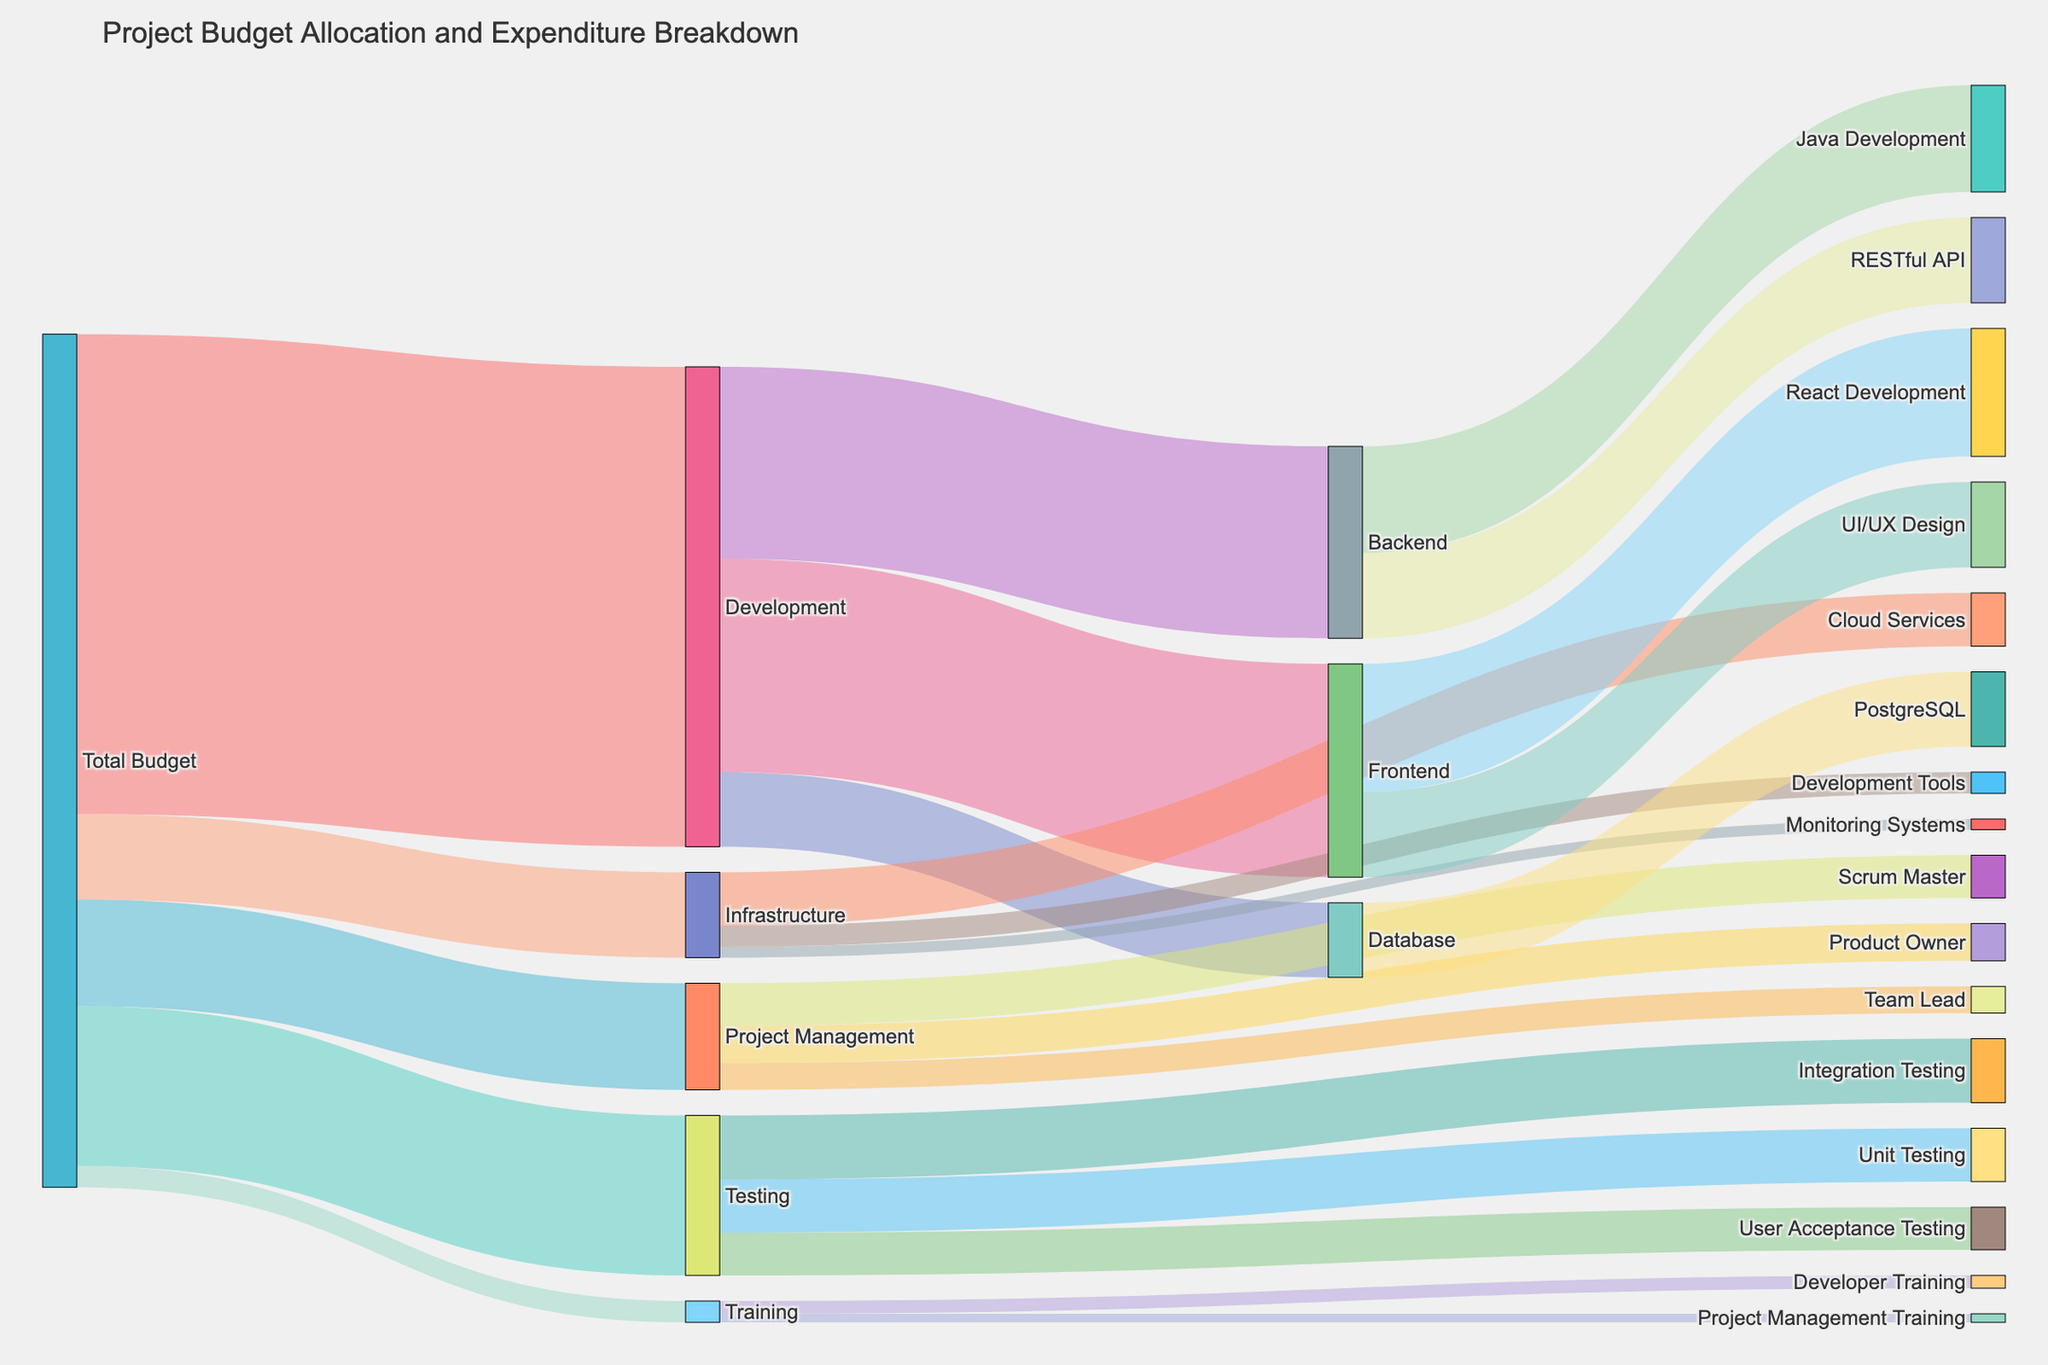what is the title of the figure? The title of the figure is typically found at the top of the visual. Look for the largest and boldest text which is usually centered.
Answer: Project Budget Allocation and Expenditure Breakdown Which budget category received the highest allocation? To determine the highest allocation, compare the budget values for each category (Development, Testing, Project Management, Infrastructure, Training). The largest value indicates the highest allocation.
Answer: Development What is the total budget allocated for Training? Locate the flow from Total Budget to Training and read the value associated with it.
Answer: 20000 How much of the Development budget is allocated to Frontend, Backend, and Database respectively? Trace the lines from Development to Frontend, Backend, and Database. Read the values associated with each of these flows.
Answer: Frontend: 200000, Backend: 180000, Database: 70000 What is the sum of the budget allocated to Unit Testing and Integration Testing? Find the values for Unit Testing and Integration Testing, which flow from Testing. Add these two values together.
Answer: 110000 How does the allocation for Java Development compare with the allocation for PostgreSQL? Trace the values for Java Development and PostgreSQL. Java Development is under Backend, and PostgreSQL is under Database. Compare their values directly.
Answer: Java Development: 100000, PostgreSQL: 70000 Which sub-category under Development received more budget, React Development or UI/UX Design? Look under the Frontend category which is part of Development and compare the values for React Development and UI/UX Design.
Answer: React Development What is the difference between the budget for Cloud Services and Monitoring Systems under Infrastructure? Look at the values for Cloud Services and Monitoring Systems in the Infrastructure category and subtract the smaller value from the larger one.
Answer: 40000 What portion of the total budget was allocated to the Project Management category? Identify the flow from Total Budget to Project Management and read its value, then compare this value with the Total Budget amount if it's given or assume the sum of all categories is the total (800000) and find the proportion.
Answer: 100000 